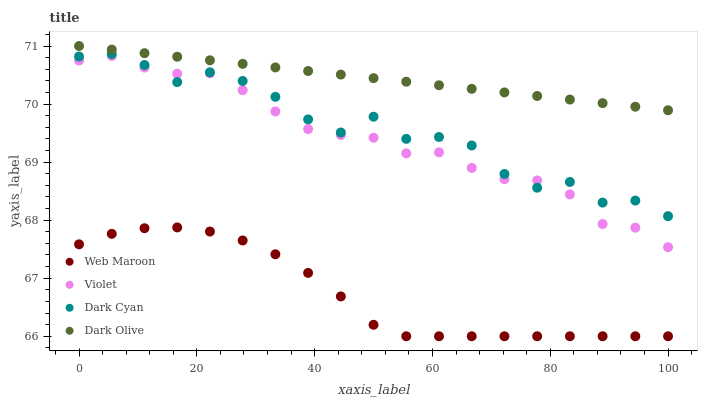Does Web Maroon have the minimum area under the curve?
Answer yes or no. Yes. Does Dark Olive have the maximum area under the curve?
Answer yes or no. Yes. Does Dark Olive have the minimum area under the curve?
Answer yes or no. No. Does Web Maroon have the maximum area under the curve?
Answer yes or no. No. Is Dark Olive the smoothest?
Answer yes or no. Yes. Is Dark Cyan the roughest?
Answer yes or no. Yes. Is Web Maroon the smoothest?
Answer yes or no. No. Is Web Maroon the roughest?
Answer yes or no. No. Does Web Maroon have the lowest value?
Answer yes or no. Yes. Does Dark Olive have the lowest value?
Answer yes or no. No. Does Dark Olive have the highest value?
Answer yes or no. Yes. Does Web Maroon have the highest value?
Answer yes or no. No. Is Web Maroon less than Violet?
Answer yes or no. Yes. Is Dark Olive greater than Dark Cyan?
Answer yes or no. Yes. Does Dark Cyan intersect Violet?
Answer yes or no. Yes. Is Dark Cyan less than Violet?
Answer yes or no. No. Is Dark Cyan greater than Violet?
Answer yes or no. No. Does Web Maroon intersect Violet?
Answer yes or no. No. 